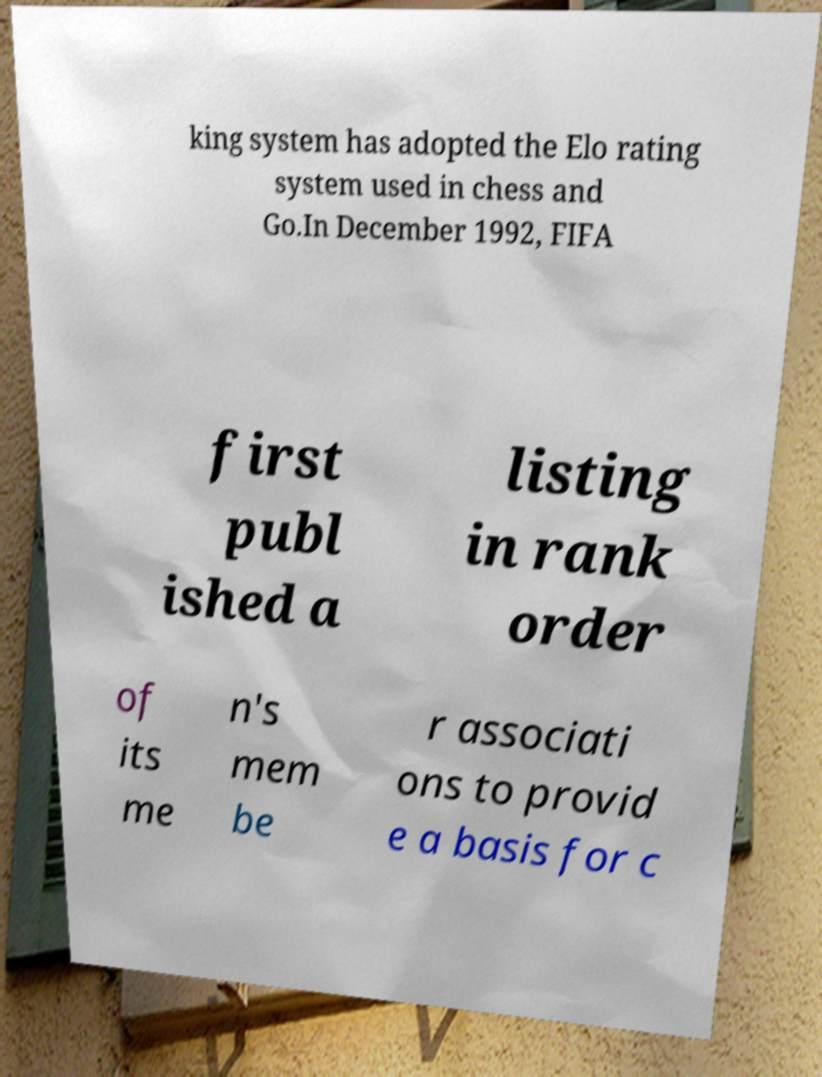I need the written content from this picture converted into text. Can you do that? king system has adopted the Elo rating system used in chess and Go.In December 1992, FIFA first publ ished a listing in rank order of its me n's mem be r associati ons to provid e a basis for c 